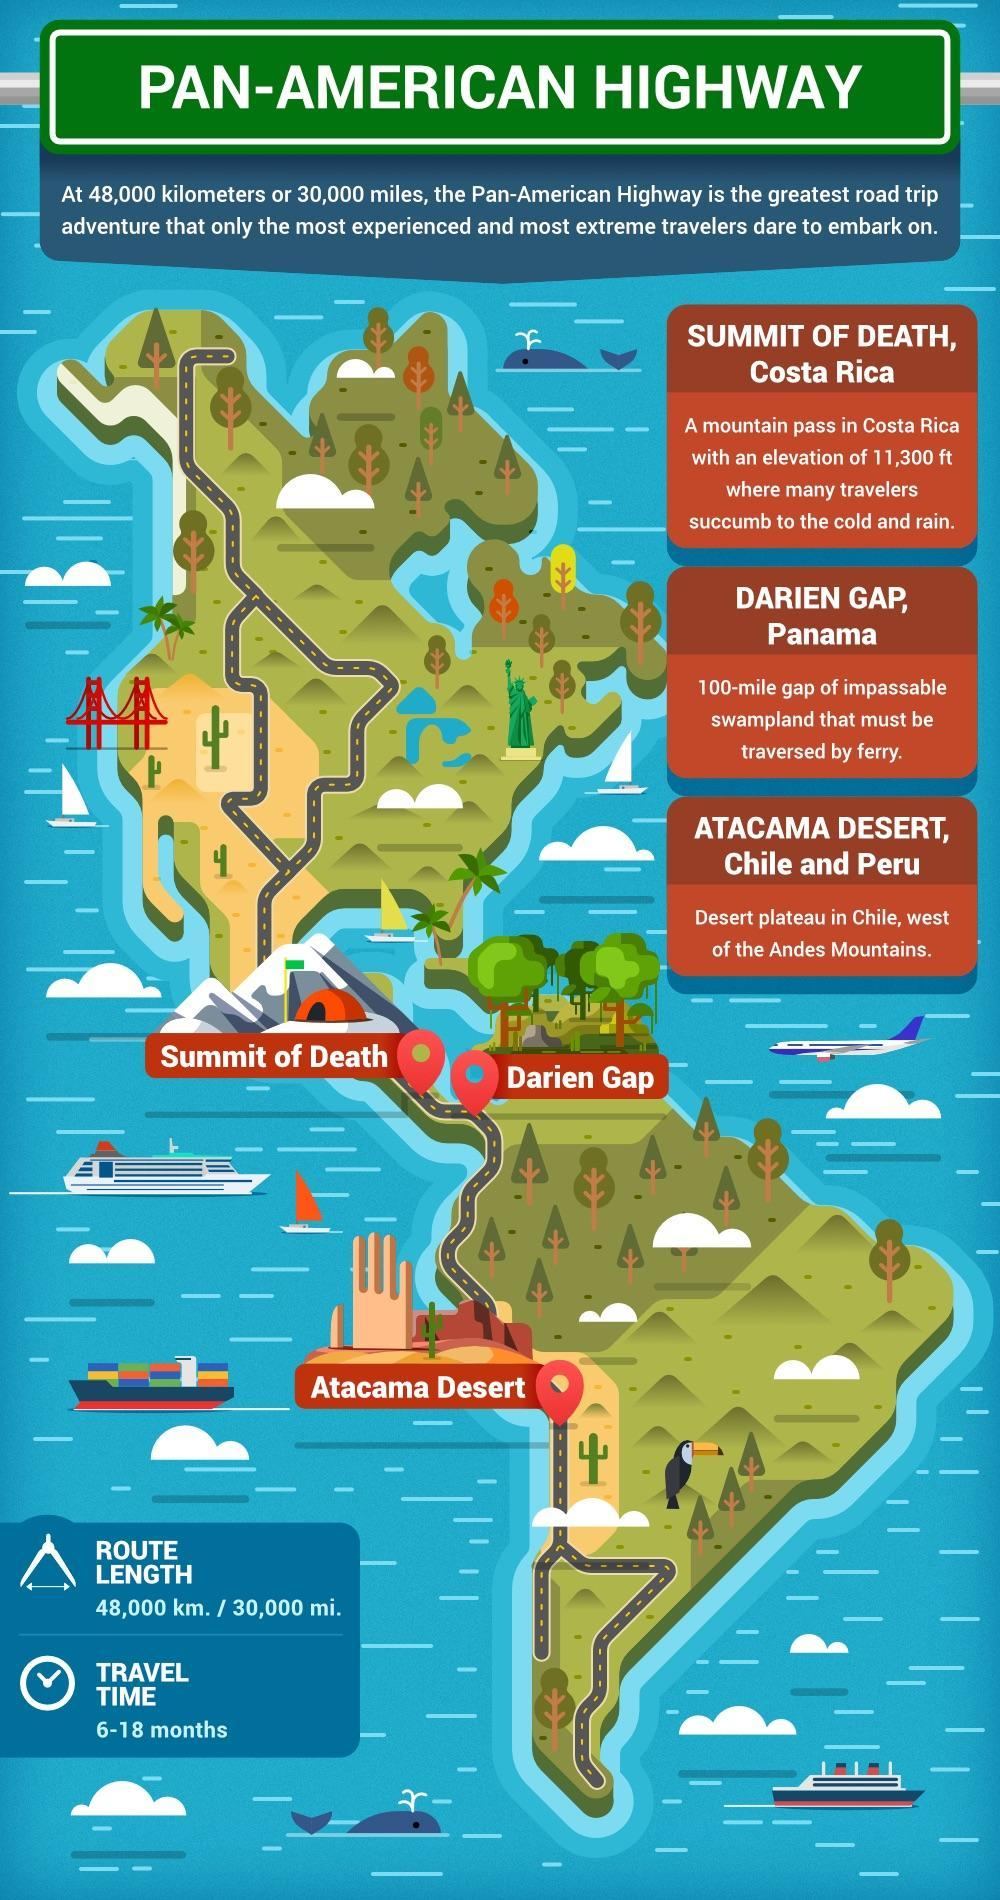Which are the three locations of most dangerous roads ?
Answer the question with a short phrase. Summit of Death, Darien Gap, Atacama Desert 